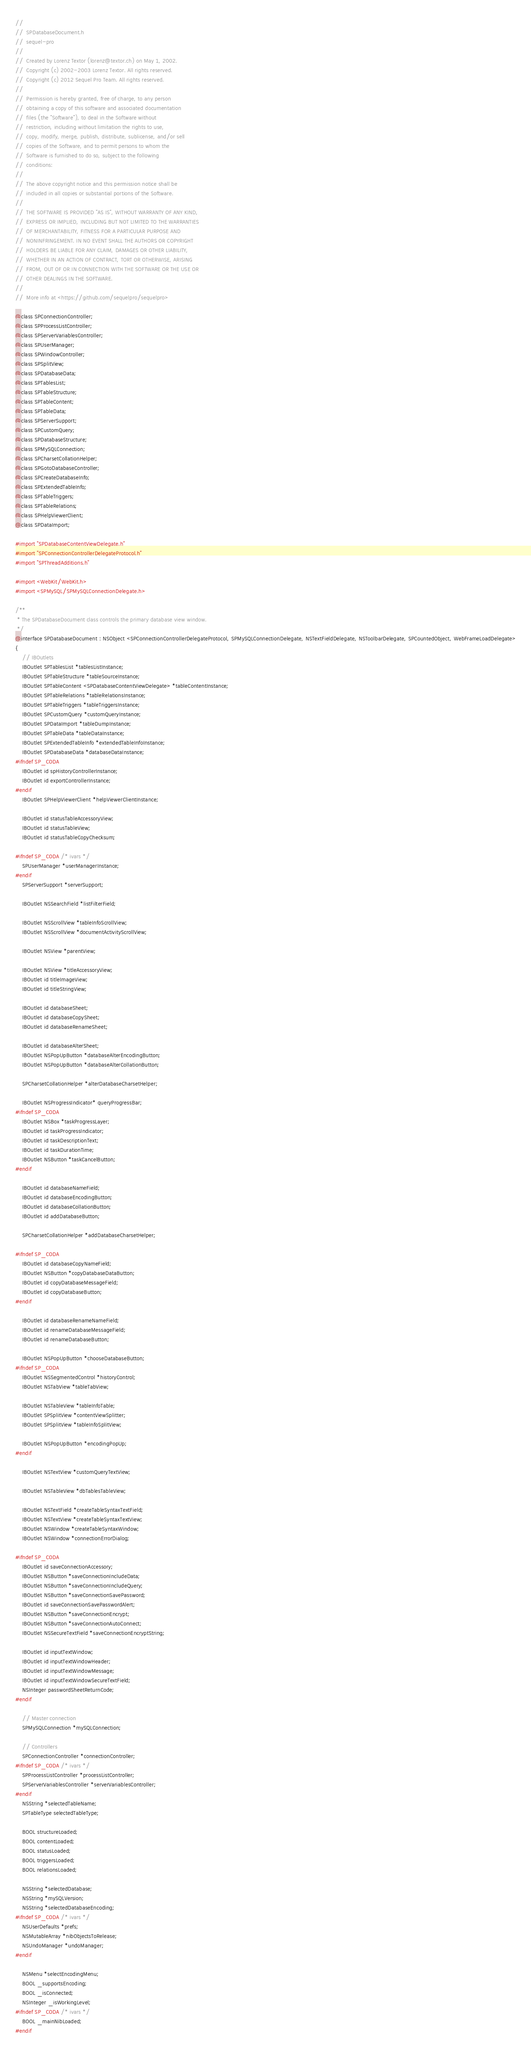Convert code to text. <code><loc_0><loc_0><loc_500><loc_500><_C_>//
//  SPDatabaseDocument.h
//  sequel-pro
//
//  Created by Lorenz Textor (lorenz@textor.ch) on May 1, 2002.
//  Copyright (c) 2002-2003 Lorenz Textor. All rights reserved.
//  Copyright (c) 2012 Sequel Pro Team. All rights reserved.
//  
//  Permission is hereby granted, free of charge, to any person
//  obtaining a copy of this software and associated documentation
//  files (the "Software"), to deal in the Software without
//  restriction, including without limitation the rights to use,
//  copy, modify, merge, publish, distribute, sublicense, and/or sell
//  copies of the Software, and to permit persons to whom the
//  Software is furnished to do so, subject to the following
//  conditions:
//
//  The above copyright notice and this permission notice shall be
//  included in all copies or substantial portions of the Software.
//
//  THE SOFTWARE IS PROVIDED "AS IS", WITHOUT WARRANTY OF ANY KIND,
//  EXPRESS OR IMPLIED, INCLUDING BUT NOT LIMITED TO THE WARRANTIES
//  OF MERCHANTABILITY, FITNESS FOR A PARTICULAR PURPOSE AND
//  NONINFRINGEMENT. IN NO EVENT SHALL THE AUTHORS OR COPYRIGHT
//  HOLDERS BE LIABLE FOR ANY CLAIM, DAMAGES OR OTHER LIABILITY,
//  WHETHER IN AN ACTION OF CONTRACT, TORT OR OTHERWISE, ARISING
//  FROM, OUT OF OR IN CONNECTION WITH THE SOFTWARE OR THE USE OR
//  OTHER DEALINGS IN THE SOFTWARE.
//
//  More info at <https://github.com/sequelpro/sequelpro>

@class SPConnectionController;
@class SPProcessListController;
@class SPServerVariablesController;
@class SPUserManager;
@class SPWindowController;
@class SPSplitView;
@class SPDatabaseData;
@class SPTablesList;
@class SPTableStructure;
@class SPTableContent;
@class SPTableData;
@class SPServerSupport;
@class SPCustomQuery;
@class SPDatabaseStructure;
@class SPMySQLConnection;
@class SPCharsetCollationHelper;
@class SPGotoDatabaseController;
@class SPCreateDatabaseInfo;
@class SPExtendedTableInfo;
@class SPTableTriggers;
@class SPTableRelations;
@class SPHelpViewerClient;
@class SPDataImport;

#import "SPDatabaseContentViewDelegate.h"
#import "SPConnectionControllerDelegateProtocol.h"
#import "SPThreadAdditions.h"

#import <WebKit/WebKit.h>
#import <SPMySQL/SPMySQLConnectionDelegate.h>

/**
 * The SPDatabaseDocument class controls the primary database view window.
 */
@interface SPDatabaseDocument : NSObject <SPConnectionControllerDelegateProtocol, SPMySQLConnectionDelegate, NSTextFieldDelegate, NSToolbarDelegate, SPCountedObject, WebFrameLoadDelegate>
{
	// IBOutlets
	IBOutlet SPTablesList *tablesListInstance;
	IBOutlet SPTableStructure *tableSourceInstance;
	IBOutlet SPTableContent <SPDatabaseContentViewDelegate> *tableContentInstance;
	IBOutlet SPTableRelations *tableRelationsInstance;
	IBOutlet SPTableTriggers *tableTriggersInstance;
	IBOutlet SPCustomQuery *customQueryInstance;
	IBOutlet SPDataImport *tableDumpInstance;
	IBOutlet SPTableData *tableDataInstance;
	IBOutlet SPExtendedTableInfo *extendedTableInfoInstance;
	IBOutlet SPDatabaseData *databaseDataInstance;
#ifndef SP_CODA
	IBOutlet id spHistoryControllerInstance;
	IBOutlet id exportControllerInstance;
#endif
	IBOutlet SPHelpViewerClient *helpViewerClientInstance;

	IBOutlet id statusTableAccessoryView;
	IBOutlet id statusTableView;
	IBOutlet id statusTableCopyChecksum;
	
#ifndef SP_CODA /* ivars */
    SPUserManager *userManagerInstance;
#endif
	SPServerSupport *serverSupport;
	
	IBOutlet NSSearchField *listFilterField;

	IBOutlet NSScrollView *tableInfoScrollView;
	IBOutlet NSScrollView *documentActivityScrollView;

	IBOutlet NSView *parentView;
	
	IBOutlet NSView *titleAccessoryView;
	IBOutlet id titleImageView;
	IBOutlet id titleStringView;
	
	IBOutlet id databaseSheet;
	IBOutlet id databaseCopySheet;
	IBOutlet id databaseRenameSheet;
	
	IBOutlet id databaseAlterSheet;
	IBOutlet NSPopUpButton *databaseAlterEncodingButton;
	IBOutlet NSPopUpButton *databaseAlterCollationButton;
	
	SPCharsetCollationHelper *alterDatabaseCharsetHelper;

	IBOutlet NSProgressIndicator* queryProgressBar;
#ifndef SP_CODA
	IBOutlet NSBox *taskProgressLayer;
	IBOutlet id taskProgressIndicator;
	IBOutlet id taskDescriptionText;
	IBOutlet id taskDurationTime;
	IBOutlet NSButton *taskCancelButton;
#endif
	
	IBOutlet id databaseNameField;
	IBOutlet id databaseEncodingButton;
	IBOutlet id databaseCollationButton;
	IBOutlet id addDatabaseButton;
	
	SPCharsetCollationHelper *addDatabaseCharsetHelper;

#ifndef SP_CODA
	IBOutlet id databaseCopyNameField;
	IBOutlet NSButton *copyDatabaseDataButton;
	IBOutlet id copyDatabaseMessageField;
	IBOutlet id copyDatabaseButton;
#endif
	
	IBOutlet id databaseRenameNameField;
	IBOutlet id renameDatabaseMessageField;
	IBOutlet id renameDatabaseButton;

	IBOutlet NSPopUpButton *chooseDatabaseButton;
#ifndef SP_CODA
	IBOutlet NSSegmentedControl *historyControl;
	IBOutlet NSTabView *tableTabView;
	
	IBOutlet NSTableView *tableInfoTable;
	IBOutlet SPSplitView *contentViewSplitter;
	IBOutlet SPSplitView *tableInfoSplitView;
	
	IBOutlet NSPopUpButton *encodingPopUp;
#endif
	
	IBOutlet NSTextView *customQueryTextView;
	
	IBOutlet NSTableView *dbTablesTableView;

	IBOutlet NSTextField *createTableSyntaxTextField;
	IBOutlet NSTextView *createTableSyntaxTextView;
	IBOutlet NSWindow *createTableSyntaxWindow;
	IBOutlet NSWindow *connectionErrorDialog;

#ifndef SP_CODA
	IBOutlet id saveConnectionAccessory;
	IBOutlet NSButton *saveConnectionIncludeData;
	IBOutlet NSButton *saveConnectionIncludeQuery;
	IBOutlet NSButton *saveConnectionSavePassword;
	IBOutlet id saveConnectionSavePasswordAlert;
	IBOutlet NSButton *saveConnectionEncrypt;
	IBOutlet NSButton *saveConnectionAutoConnect;
	IBOutlet NSSecureTextField *saveConnectionEncryptString;
	
	IBOutlet id inputTextWindow;
	IBOutlet id inputTextWindowHeader;
	IBOutlet id inputTextWindowMessage;
	IBOutlet id inputTextWindowSecureTextField;
	NSInteger passwordSheetReturnCode;
#endif
	
	// Master connection
	SPMySQLConnection *mySQLConnection;

	// Controllers
	SPConnectionController *connectionController;
#ifndef SP_CODA /* ivars */
	SPProcessListController *processListController;
	SPServerVariablesController *serverVariablesController;
#endif
	NSString *selectedTableName;
	SPTableType selectedTableType;

	BOOL structureLoaded;
	BOOL contentLoaded;
	BOOL statusLoaded;
	BOOL triggersLoaded;
	BOOL relationsLoaded;

	NSString *selectedDatabase;
	NSString *mySQLVersion;
	NSString *selectedDatabaseEncoding;
#ifndef SP_CODA /* ivars */
	NSUserDefaults *prefs;
	NSMutableArray *nibObjectsToRelease;
	NSUndoManager *undoManager;
#endif

	NSMenu *selectEncodingMenu;
	BOOL _supportsEncoding;
	BOOL _isConnected;
	NSInteger _isWorkingLevel;
#ifndef SP_CODA /* ivars */
	BOOL _mainNibLoaded;
#endif</code> 